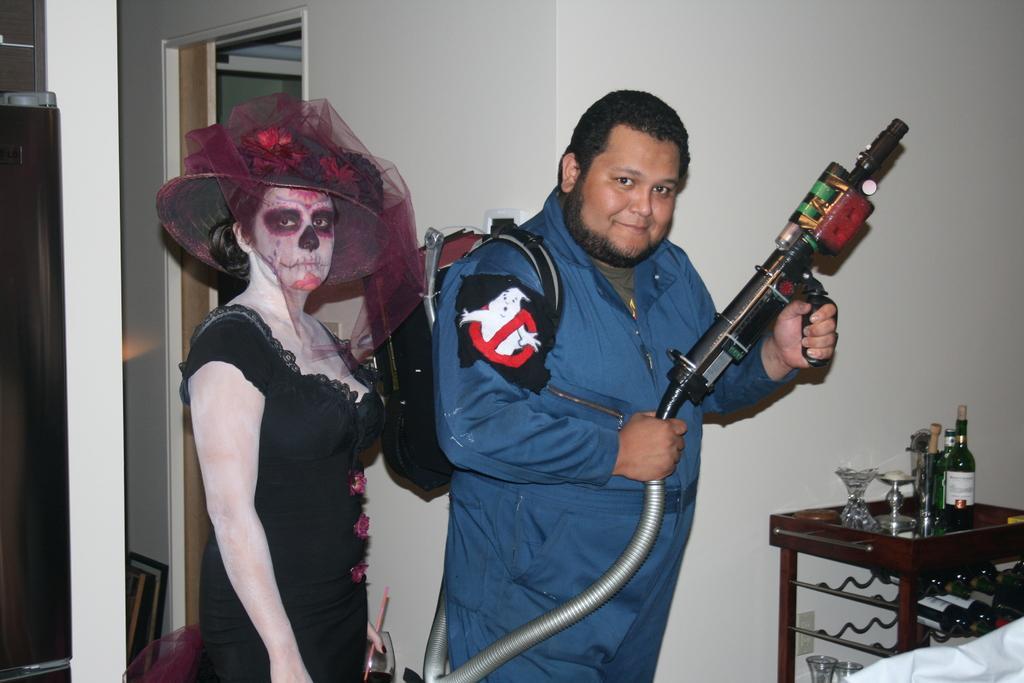Please provide a concise description of this image. This image is taken inside a room. There are two persons in this room, a man and a woman. In the right side of the image there is a table with few things on it. In the middle of the image a man is standing and holding a gun in his hand, beside him a woman is standing. She is wearing a hat. In the background there is a wall with door. 